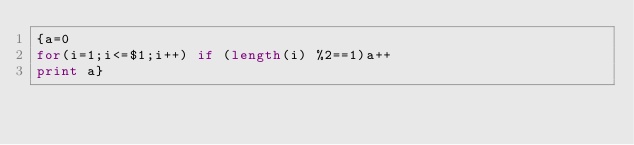<code> <loc_0><loc_0><loc_500><loc_500><_Awk_>{a=0
for(i=1;i<=$1;i++) if (length(i) %2==1)a++
print a}</code> 